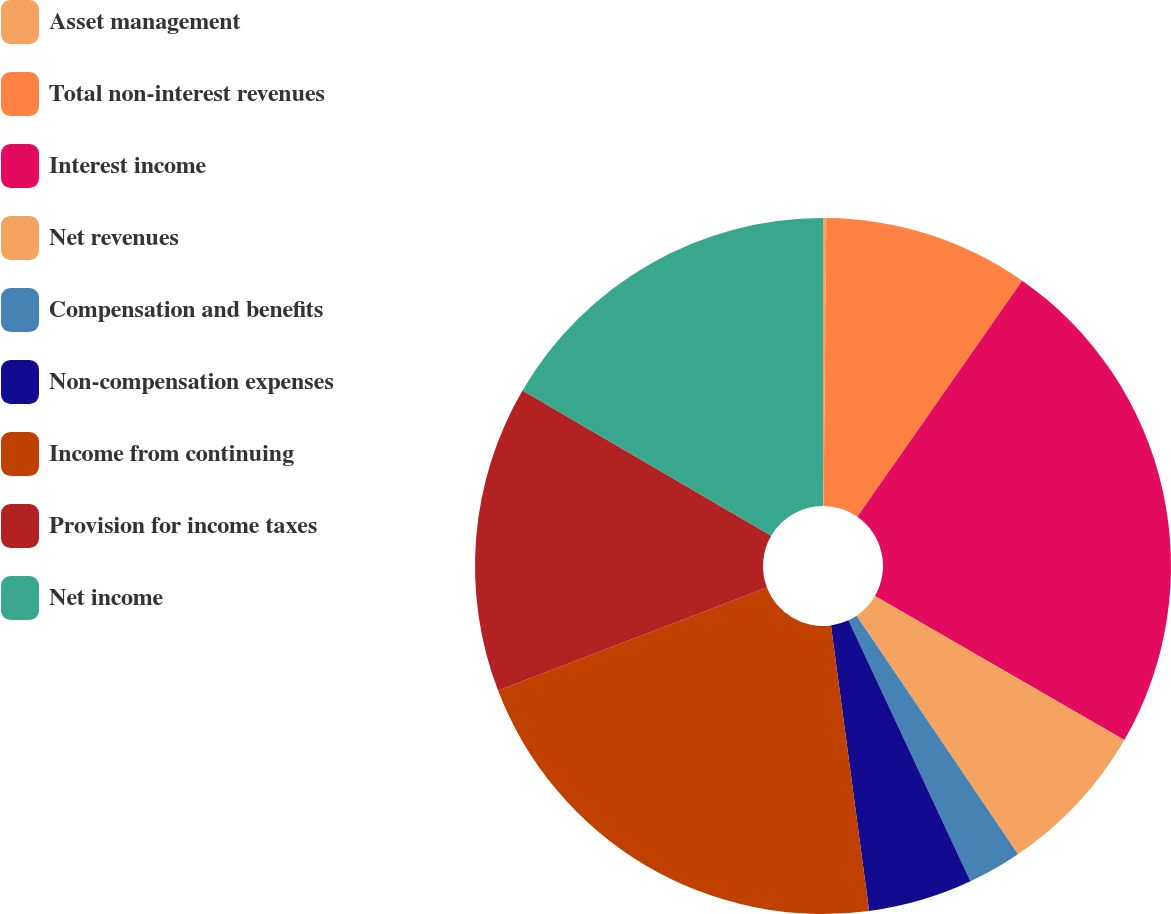Convert chart. <chart><loc_0><loc_0><loc_500><loc_500><pie_chart><fcel>Asset management<fcel>Total non-interest revenues<fcel>Interest income<fcel>Net revenues<fcel>Compensation and benefits<fcel>Non-compensation expenses<fcel>Income from continuing<fcel>Provision for income taxes<fcel>Net income<nl><fcel>0.15%<fcel>9.55%<fcel>23.64%<fcel>7.2%<fcel>2.5%<fcel>4.85%<fcel>21.29%<fcel>14.24%<fcel>16.59%<nl></chart> 